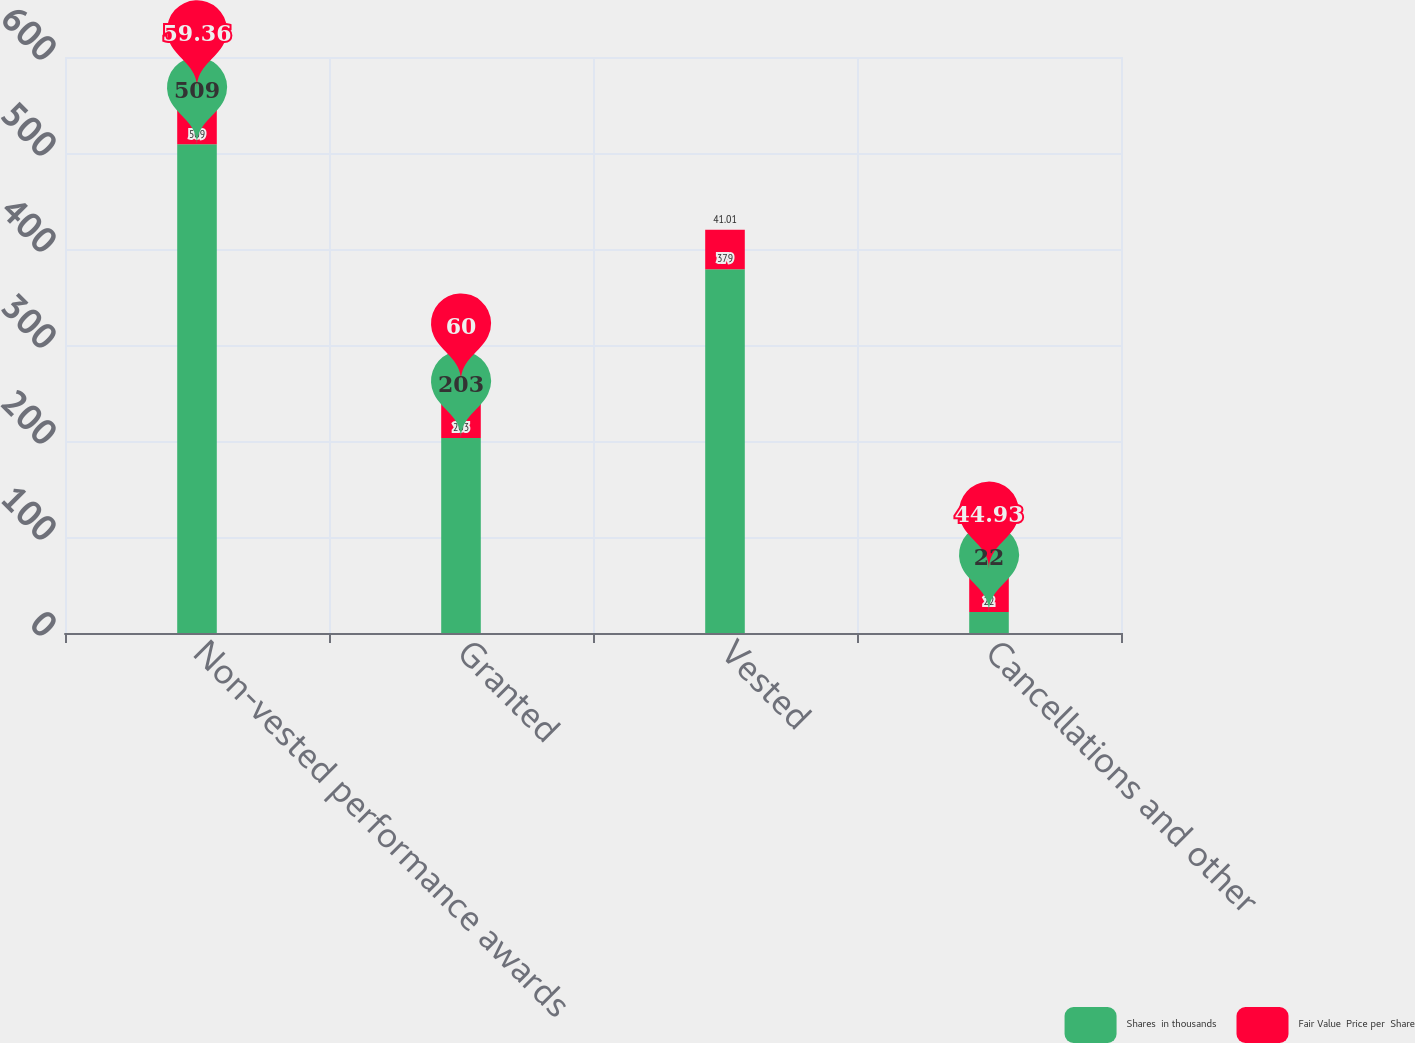Convert chart to OTSL. <chart><loc_0><loc_0><loc_500><loc_500><stacked_bar_chart><ecel><fcel>Non-vested performance awards<fcel>Granted<fcel>Vested<fcel>Cancellations and other<nl><fcel>Shares  in thousands<fcel>509<fcel>203<fcel>379<fcel>22<nl><fcel>Fair Value  Price per  Share<fcel>59.36<fcel>60<fcel>41.01<fcel>44.93<nl></chart> 